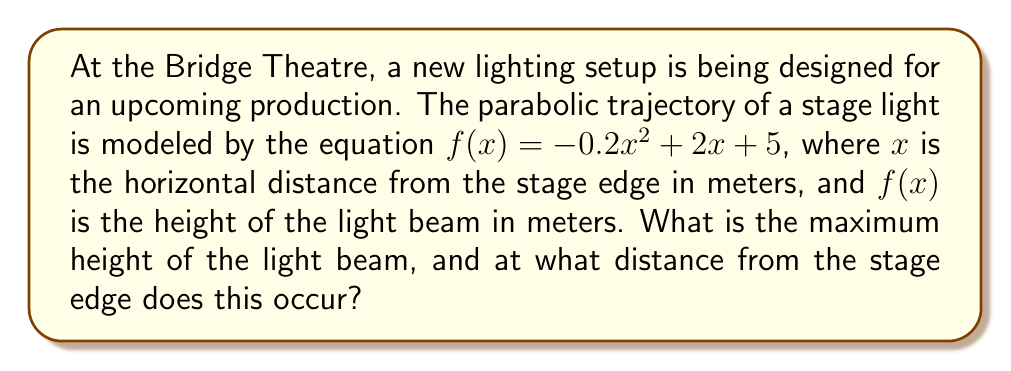Could you help me with this problem? To solve this problem, we'll follow these steps:

1) The given equation $f(x) = -0.2x^2 + 2x + 5$ is in the form of a quadratic function $f(x) = ax^2 + bx + c$, where:
   $a = -0.2$
   $b = 2$
   $c = 5$

2) For a quadratic function, the x-coordinate of the vertex (which gives the maximum or minimum point) is given by the formula:
   
   $$x = -\frac{b}{2a}$$

3) Substituting our values:
   
   $$x = -\frac{2}{2(-0.2)} = -\frac{2}{-0.4} = 5$$

4) To find the maximum height (y-coordinate of the vertex), we substitute this x-value back into the original equation:

   $$f(5) = -0.2(5)^2 + 2(5) + 5$$
   $$    = -0.2(25) + 10 + 5$$
   $$    = -5 + 10 + 5$$
   $$    = 10$$

5) Therefore, the maximum height of the light beam is 10 meters, occurring at a distance of 5 meters from the stage edge.
Answer: Maximum height: 10 meters; Distance from stage edge: 5 meters 